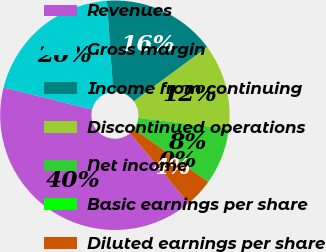Convert chart. <chart><loc_0><loc_0><loc_500><loc_500><pie_chart><fcel>Revenues<fcel>Gross margin<fcel>Income from continuing<fcel>Discontinued operations<fcel>Net income<fcel>Basic earnings per share<fcel>Diluted earnings per share<nl><fcel>40.0%<fcel>20.0%<fcel>16.0%<fcel>12.0%<fcel>8.0%<fcel>0.0%<fcel>4.0%<nl></chart> 